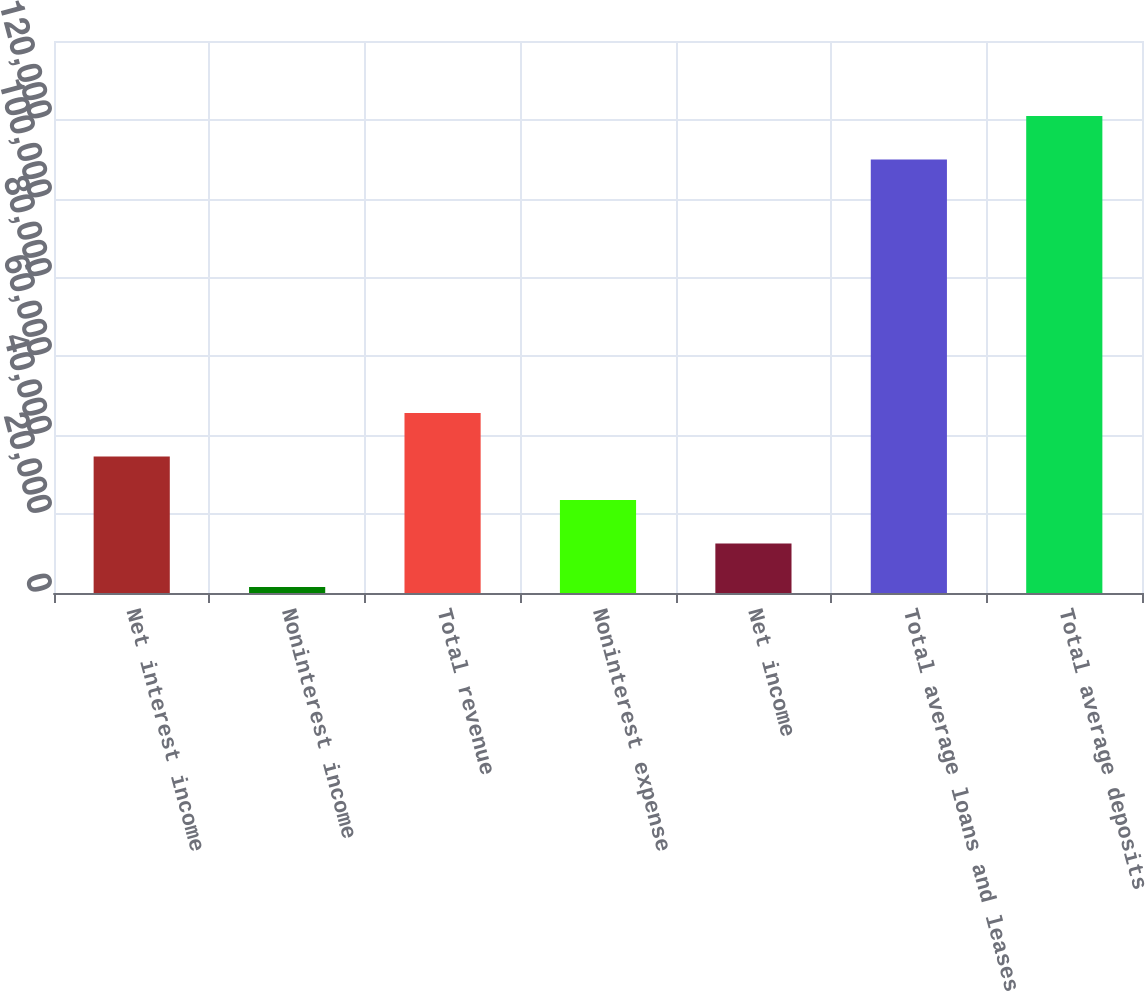Convert chart to OTSL. <chart><loc_0><loc_0><loc_500><loc_500><bar_chart><fcel>Net interest income<fcel>Noninterest income<fcel>Total revenue<fcel>Noninterest expense<fcel>Net income<fcel>Total average loans and leases<fcel>Total average deposits<nl><fcel>34636<fcel>1534<fcel>45670<fcel>23602<fcel>12568<fcel>109972<fcel>121006<nl></chart> 